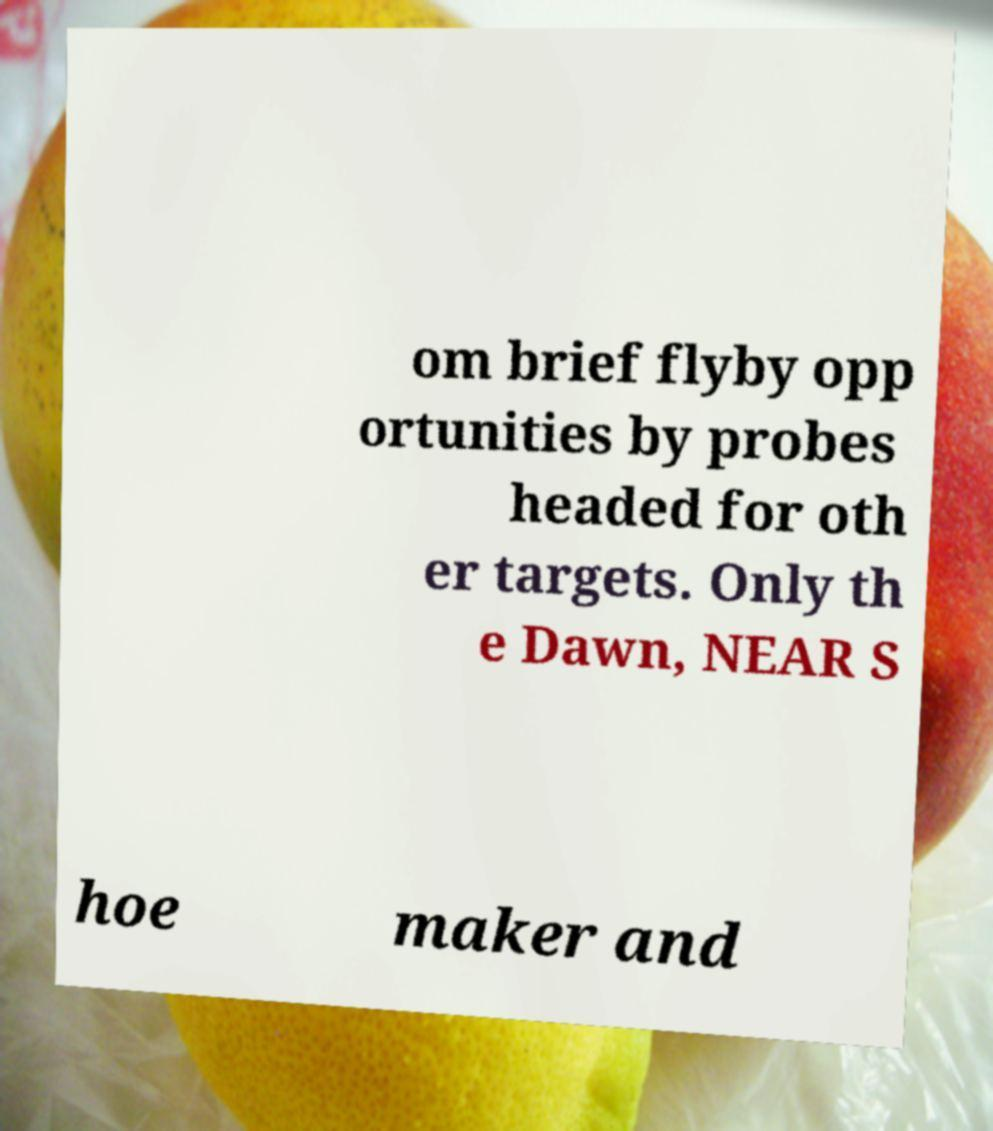For documentation purposes, I need the text within this image transcribed. Could you provide that? om brief flyby opp ortunities by probes headed for oth er targets. Only th e Dawn, NEAR S hoe maker and 